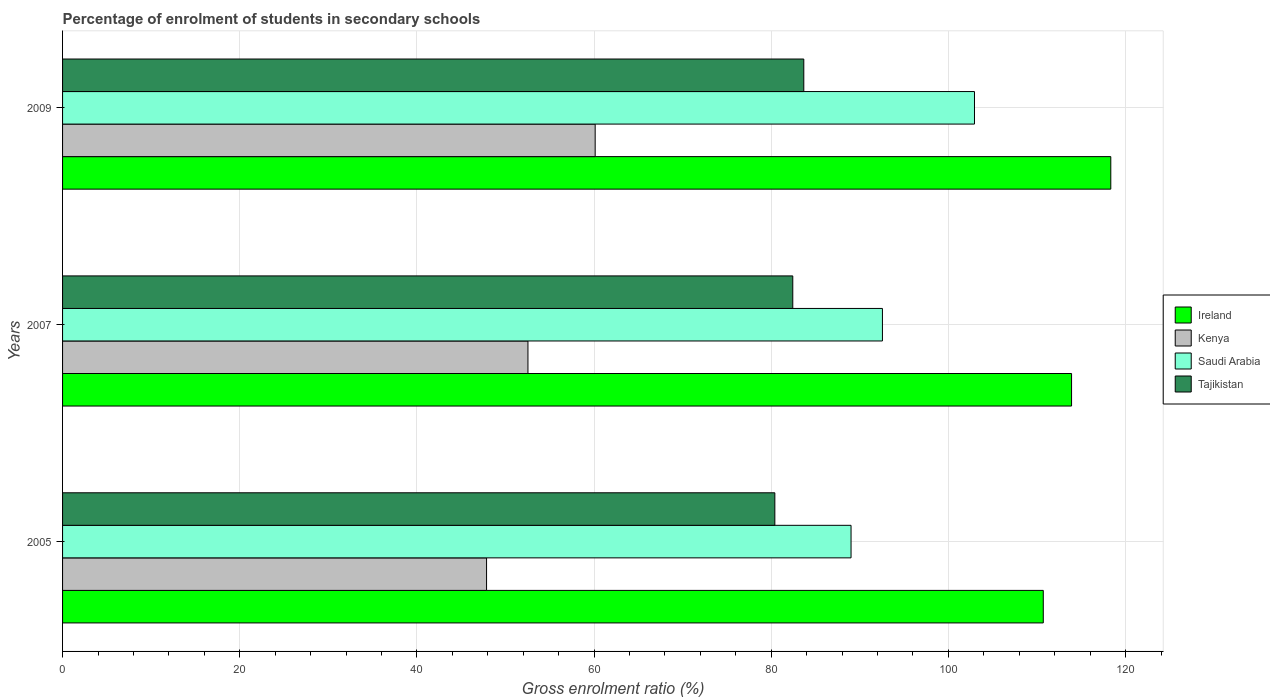How many groups of bars are there?
Make the answer very short. 3. How many bars are there on the 1st tick from the top?
Give a very brief answer. 4. How many bars are there on the 2nd tick from the bottom?
Provide a succinct answer. 4. In how many cases, is the number of bars for a given year not equal to the number of legend labels?
Ensure brevity in your answer.  0. What is the percentage of students enrolled in secondary schools in Ireland in 2005?
Your answer should be very brief. 110.71. Across all years, what is the maximum percentage of students enrolled in secondary schools in Tajikistan?
Provide a short and direct response. 83.67. Across all years, what is the minimum percentage of students enrolled in secondary schools in Kenya?
Give a very brief answer. 47.86. In which year was the percentage of students enrolled in secondary schools in Kenya maximum?
Provide a succinct answer. 2009. In which year was the percentage of students enrolled in secondary schools in Saudi Arabia minimum?
Your response must be concise. 2005. What is the total percentage of students enrolled in secondary schools in Tajikistan in the graph?
Your response must be concise. 246.51. What is the difference between the percentage of students enrolled in secondary schools in Saudi Arabia in 2005 and that in 2009?
Make the answer very short. -13.94. What is the difference between the percentage of students enrolled in secondary schools in Ireland in 2009 and the percentage of students enrolled in secondary schools in Kenya in 2007?
Provide a short and direct response. 65.8. What is the average percentage of students enrolled in secondary schools in Tajikistan per year?
Make the answer very short. 82.17. In the year 2007, what is the difference between the percentage of students enrolled in secondary schools in Saudi Arabia and percentage of students enrolled in secondary schools in Tajikistan?
Offer a terse response. 10.12. In how many years, is the percentage of students enrolled in secondary schools in Ireland greater than 100 %?
Your answer should be compact. 3. What is the ratio of the percentage of students enrolled in secondary schools in Kenya in 2005 to that in 2007?
Make the answer very short. 0.91. Is the percentage of students enrolled in secondary schools in Ireland in 2005 less than that in 2007?
Offer a terse response. Yes. What is the difference between the highest and the second highest percentage of students enrolled in secondary schools in Saudi Arabia?
Provide a short and direct response. 10.39. What is the difference between the highest and the lowest percentage of students enrolled in secondary schools in Tajikistan?
Give a very brief answer. 3.27. Is the sum of the percentage of students enrolled in secondary schools in Kenya in 2005 and 2007 greater than the maximum percentage of students enrolled in secondary schools in Saudi Arabia across all years?
Provide a succinct answer. No. What does the 4th bar from the top in 2005 represents?
Your answer should be compact. Ireland. What does the 2nd bar from the bottom in 2005 represents?
Your answer should be very brief. Kenya. Are all the bars in the graph horizontal?
Make the answer very short. Yes. How many years are there in the graph?
Ensure brevity in your answer.  3. Are the values on the major ticks of X-axis written in scientific E-notation?
Offer a terse response. No. Does the graph contain any zero values?
Your answer should be compact. No. How many legend labels are there?
Your response must be concise. 4. What is the title of the graph?
Your answer should be very brief. Percentage of enrolment of students in secondary schools. Does "Vanuatu" appear as one of the legend labels in the graph?
Provide a short and direct response. No. What is the label or title of the X-axis?
Give a very brief answer. Gross enrolment ratio (%). What is the label or title of the Y-axis?
Your response must be concise. Years. What is the Gross enrolment ratio (%) in Ireland in 2005?
Your answer should be very brief. 110.71. What is the Gross enrolment ratio (%) of Kenya in 2005?
Keep it short and to the point. 47.86. What is the Gross enrolment ratio (%) of Saudi Arabia in 2005?
Keep it short and to the point. 89.01. What is the Gross enrolment ratio (%) of Tajikistan in 2005?
Give a very brief answer. 80.41. What is the Gross enrolment ratio (%) of Ireland in 2007?
Your answer should be compact. 113.9. What is the Gross enrolment ratio (%) of Kenya in 2007?
Your answer should be very brief. 52.53. What is the Gross enrolment ratio (%) of Saudi Arabia in 2007?
Offer a terse response. 92.55. What is the Gross enrolment ratio (%) in Tajikistan in 2007?
Give a very brief answer. 82.43. What is the Gross enrolment ratio (%) in Ireland in 2009?
Make the answer very short. 118.33. What is the Gross enrolment ratio (%) in Kenya in 2009?
Provide a short and direct response. 60.12. What is the Gross enrolment ratio (%) in Saudi Arabia in 2009?
Your answer should be very brief. 102.94. What is the Gross enrolment ratio (%) of Tajikistan in 2009?
Make the answer very short. 83.67. Across all years, what is the maximum Gross enrolment ratio (%) in Ireland?
Ensure brevity in your answer.  118.33. Across all years, what is the maximum Gross enrolment ratio (%) of Kenya?
Provide a short and direct response. 60.12. Across all years, what is the maximum Gross enrolment ratio (%) of Saudi Arabia?
Make the answer very short. 102.94. Across all years, what is the maximum Gross enrolment ratio (%) of Tajikistan?
Provide a succinct answer. 83.67. Across all years, what is the minimum Gross enrolment ratio (%) in Ireland?
Offer a terse response. 110.71. Across all years, what is the minimum Gross enrolment ratio (%) of Kenya?
Your answer should be very brief. 47.86. Across all years, what is the minimum Gross enrolment ratio (%) of Saudi Arabia?
Make the answer very short. 89.01. Across all years, what is the minimum Gross enrolment ratio (%) in Tajikistan?
Give a very brief answer. 80.41. What is the total Gross enrolment ratio (%) in Ireland in the graph?
Your answer should be very brief. 342.94. What is the total Gross enrolment ratio (%) in Kenya in the graph?
Provide a succinct answer. 160.52. What is the total Gross enrolment ratio (%) of Saudi Arabia in the graph?
Give a very brief answer. 284.5. What is the total Gross enrolment ratio (%) in Tajikistan in the graph?
Offer a very short reply. 246.51. What is the difference between the Gross enrolment ratio (%) in Ireland in 2005 and that in 2007?
Offer a very short reply. -3.19. What is the difference between the Gross enrolment ratio (%) of Kenya in 2005 and that in 2007?
Your answer should be compact. -4.67. What is the difference between the Gross enrolment ratio (%) of Saudi Arabia in 2005 and that in 2007?
Make the answer very short. -3.54. What is the difference between the Gross enrolment ratio (%) of Tajikistan in 2005 and that in 2007?
Provide a short and direct response. -2.02. What is the difference between the Gross enrolment ratio (%) in Ireland in 2005 and that in 2009?
Your answer should be compact. -7.62. What is the difference between the Gross enrolment ratio (%) of Kenya in 2005 and that in 2009?
Your answer should be compact. -12.26. What is the difference between the Gross enrolment ratio (%) in Saudi Arabia in 2005 and that in 2009?
Your response must be concise. -13.94. What is the difference between the Gross enrolment ratio (%) of Tajikistan in 2005 and that in 2009?
Your answer should be very brief. -3.27. What is the difference between the Gross enrolment ratio (%) in Ireland in 2007 and that in 2009?
Your response must be concise. -4.43. What is the difference between the Gross enrolment ratio (%) in Kenya in 2007 and that in 2009?
Offer a terse response. -7.59. What is the difference between the Gross enrolment ratio (%) of Saudi Arabia in 2007 and that in 2009?
Provide a short and direct response. -10.39. What is the difference between the Gross enrolment ratio (%) in Tajikistan in 2007 and that in 2009?
Your answer should be very brief. -1.24. What is the difference between the Gross enrolment ratio (%) of Ireland in 2005 and the Gross enrolment ratio (%) of Kenya in 2007?
Ensure brevity in your answer.  58.17. What is the difference between the Gross enrolment ratio (%) of Ireland in 2005 and the Gross enrolment ratio (%) of Saudi Arabia in 2007?
Your answer should be very brief. 18.16. What is the difference between the Gross enrolment ratio (%) in Ireland in 2005 and the Gross enrolment ratio (%) in Tajikistan in 2007?
Offer a very short reply. 28.28. What is the difference between the Gross enrolment ratio (%) of Kenya in 2005 and the Gross enrolment ratio (%) of Saudi Arabia in 2007?
Keep it short and to the point. -44.69. What is the difference between the Gross enrolment ratio (%) in Kenya in 2005 and the Gross enrolment ratio (%) in Tajikistan in 2007?
Keep it short and to the point. -34.57. What is the difference between the Gross enrolment ratio (%) of Saudi Arabia in 2005 and the Gross enrolment ratio (%) of Tajikistan in 2007?
Provide a short and direct response. 6.58. What is the difference between the Gross enrolment ratio (%) in Ireland in 2005 and the Gross enrolment ratio (%) in Kenya in 2009?
Provide a succinct answer. 50.58. What is the difference between the Gross enrolment ratio (%) of Ireland in 2005 and the Gross enrolment ratio (%) of Saudi Arabia in 2009?
Ensure brevity in your answer.  7.77. What is the difference between the Gross enrolment ratio (%) in Ireland in 2005 and the Gross enrolment ratio (%) in Tajikistan in 2009?
Make the answer very short. 27.03. What is the difference between the Gross enrolment ratio (%) of Kenya in 2005 and the Gross enrolment ratio (%) of Saudi Arabia in 2009?
Give a very brief answer. -55.08. What is the difference between the Gross enrolment ratio (%) of Kenya in 2005 and the Gross enrolment ratio (%) of Tajikistan in 2009?
Make the answer very short. -35.81. What is the difference between the Gross enrolment ratio (%) in Saudi Arabia in 2005 and the Gross enrolment ratio (%) in Tajikistan in 2009?
Provide a succinct answer. 5.33. What is the difference between the Gross enrolment ratio (%) in Ireland in 2007 and the Gross enrolment ratio (%) in Kenya in 2009?
Ensure brevity in your answer.  53.78. What is the difference between the Gross enrolment ratio (%) of Ireland in 2007 and the Gross enrolment ratio (%) of Saudi Arabia in 2009?
Provide a short and direct response. 10.96. What is the difference between the Gross enrolment ratio (%) of Ireland in 2007 and the Gross enrolment ratio (%) of Tajikistan in 2009?
Your answer should be very brief. 30.23. What is the difference between the Gross enrolment ratio (%) of Kenya in 2007 and the Gross enrolment ratio (%) of Saudi Arabia in 2009?
Ensure brevity in your answer.  -50.41. What is the difference between the Gross enrolment ratio (%) in Kenya in 2007 and the Gross enrolment ratio (%) in Tajikistan in 2009?
Make the answer very short. -31.14. What is the difference between the Gross enrolment ratio (%) in Saudi Arabia in 2007 and the Gross enrolment ratio (%) in Tajikistan in 2009?
Make the answer very short. 8.88. What is the average Gross enrolment ratio (%) of Ireland per year?
Make the answer very short. 114.31. What is the average Gross enrolment ratio (%) in Kenya per year?
Provide a succinct answer. 53.51. What is the average Gross enrolment ratio (%) of Saudi Arabia per year?
Offer a very short reply. 94.83. What is the average Gross enrolment ratio (%) in Tajikistan per year?
Offer a terse response. 82.17. In the year 2005, what is the difference between the Gross enrolment ratio (%) of Ireland and Gross enrolment ratio (%) of Kenya?
Make the answer very short. 62.84. In the year 2005, what is the difference between the Gross enrolment ratio (%) in Ireland and Gross enrolment ratio (%) in Saudi Arabia?
Offer a terse response. 21.7. In the year 2005, what is the difference between the Gross enrolment ratio (%) of Ireland and Gross enrolment ratio (%) of Tajikistan?
Your answer should be compact. 30.3. In the year 2005, what is the difference between the Gross enrolment ratio (%) of Kenya and Gross enrolment ratio (%) of Saudi Arabia?
Keep it short and to the point. -41.14. In the year 2005, what is the difference between the Gross enrolment ratio (%) of Kenya and Gross enrolment ratio (%) of Tajikistan?
Provide a succinct answer. -32.54. In the year 2005, what is the difference between the Gross enrolment ratio (%) in Saudi Arabia and Gross enrolment ratio (%) in Tajikistan?
Provide a short and direct response. 8.6. In the year 2007, what is the difference between the Gross enrolment ratio (%) of Ireland and Gross enrolment ratio (%) of Kenya?
Your answer should be very brief. 61.37. In the year 2007, what is the difference between the Gross enrolment ratio (%) in Ireland and Gross enrolment ratio (%) in Saudi Arabia?
Make the answer very short. 21.35. In the year 2007, what is the difference between the Gross enrolment ratio (%) in Ireland and Gross enrolment ratio (%) in Tajikistan?
Provide a short and direct response. 31.47. In the year 2007, what is the difference between the Gross enrolment ratio (%) in Kenya and Gross enrolment ratio (%) in Saudi Arabia?
Make the answer very short. -40.02. In the year 2007, what is the difference between the Gross enrolment ratio (%) of Kenya and Gross enrolment ratio (%) of Tajikistan?
Ensure brevity in your answer.  -29.89. In the year 2007, what is the difference between the Gross enrolment ratio (%) of Saudi Arabia and Gross enrolment ratio (%) of Tajikistan?
Give a very brief answer. 10.12. In the year 2009, what is the difference between the Gross enrolment ratio (%) in Ireland and Gross enrolment ratio (%) in Kenya?
Ensure brevity in your answer.  58.21. In the year 2009, what is the difference between the Gross enrolment ratio (%) of Ireland and Gross enrolment ratio (%) of Saudi Arabia?
Provide a succinct answer. 15.39. In the year 2009, what is the difference between the Gross enrolment ratio (%) of Ireland and Gross enrolment ratio (%) of Tajikistan?
Provide a succinct answer. 34.66. In the year 2009, what is the difference between the Gross enrolment ratio (%) of Kenya and Gross enrolment ratio (%) of Saudi Arabia?
Offer a very short reply. -42.82. In the year 2009, what is the difference between the Gross enrolment ratio (%) in Kenya and Gross enrolment ratio (%) in Tajikistan?
Keep it short and to the point. -23.55. In the year 2009, what is the difference between the Gross enrolment ratio (%) of Saudi Arabia and Gross enrolment ratio (%) of Tajikistan?
Offer a terse response. 19.27. What is the ratio of the Gross enrolment ratio (%) of Ireland in 2005 to that in 2007?
Give a very brief answer. 0.97. What is the ratio of the Gross enrolment ratio (%) in Kenya in 2005 to that in 2007?
Your answer should be compact. 0.91. What is the ratio of the Gross enrolment ratio (%) in Saudi Arabia in 2005 to that in 2007?
Give a very brief answer. 0.96. What is the ratio of the Gross enrolment ratio (%) of Tajikistan in 2005 to that in 2007?
Keep it short and to the point. 0.98. What is the ratio of the Gross enrolment ratio (%) of Ireland in 2005 to that in 2009?
Offer a very short reply. 0.94. What is the ratio of the Gross enrolment ratio (%) of Kenya in 2005 to that in 2009?
Keep it short and to the point. 0.8. What is the ratio of the Gross enrolment ratio (%) in Saudi Arabia in 2005 to that in 2009?
Provide a short and direct response. 0.86. What is the ratio of the Gross enrolment ratio (%) in Tajikistan in 2005 to that in 2009?
Provide a succinct answer. 0.96. What is the ratio of the Gross enrolment ratio (%) in Ireland in 2007 to that in 2009?
Give a very brief answer. 0.96. What is the ratio of the Gross enrolment ratio (%) in Kenya in 2007 to that in 2009?
Your response must be concise. 0.87. What is the ratio of the Gross enrolment ratio (%) in Saudi Arabia in 2007 to that in 2009?
Provide a short and direct response. 0.9. What is the ratio of the Gross enrolment ratio (%) in Tajikistan in 2007 to that in 2009?
Offer a very short reply. 0.99. What is the difference between the highest and the second highest Gross enrolment ratio (%) of Ireland?
Give a very brief answer. 4.43. What is the difference between the highest and the second highest Gross enrolment ratio (%) in Kenya?
Offer a very short reply. 7.59. What is the difference between the highest and the second highest Gross enrolment ratio (%) of Saudi Arabia?
Provide a succinct answer. 10.39. What is the difference between the highest and the second highest Gross enrolment ratio (%) of Tajikistan?
Offer a terse response. 1.24. What is the difference between the highest and the lowest Gross enrolment ratio (%) of Ireland?
Offer a very short reply. 7.62. What is the difference between the highest and the lowest Gross enrolment ratio (%) in Kenya?
Your answer should be compact. 12.26. What is the difference between the highest and the lowest Gross enrolment ratio (%) in Saudi Arabia?
Give a very brief answer. 13.94. What is the difference between the highest and the lowest Gross enrolment ratio (%) of Tajikistan?
Provide a short and direct response. 3.27. 